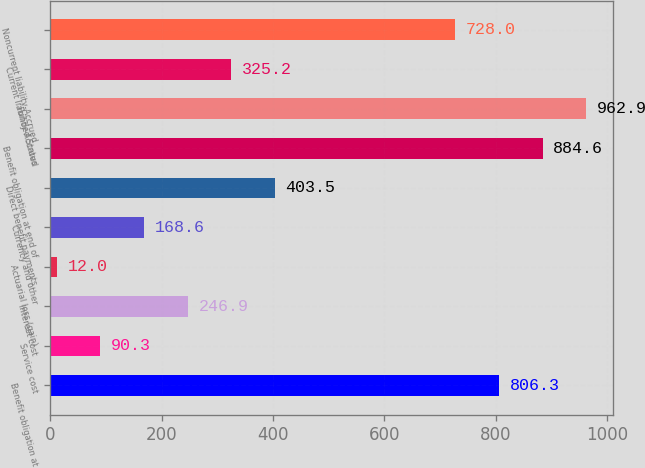Convert chart to OTSL. <chart><loc_0><loc_0><loc_500><loc_500><bar_chart><fcel>Benefit obligation at<fcel>Service cost<fcel>Interest cost<fcel>Actuarial loss (gain)<fcel>Currency and other<fcel>Direct benefit payments<fcel>Benefit obligation at end of<fcel>Funded Status<fcel>Current liability-Accrued<fcel>Noncurrent liability-Accrued<nl><fcel>806.3<fcel>90.3<fcel>246.9<fcel>12<fcel>168.6<fcel>403.5<fcel>884.6<fcel>962.9<fcel>325.2<fcel>728<nl></chart> 